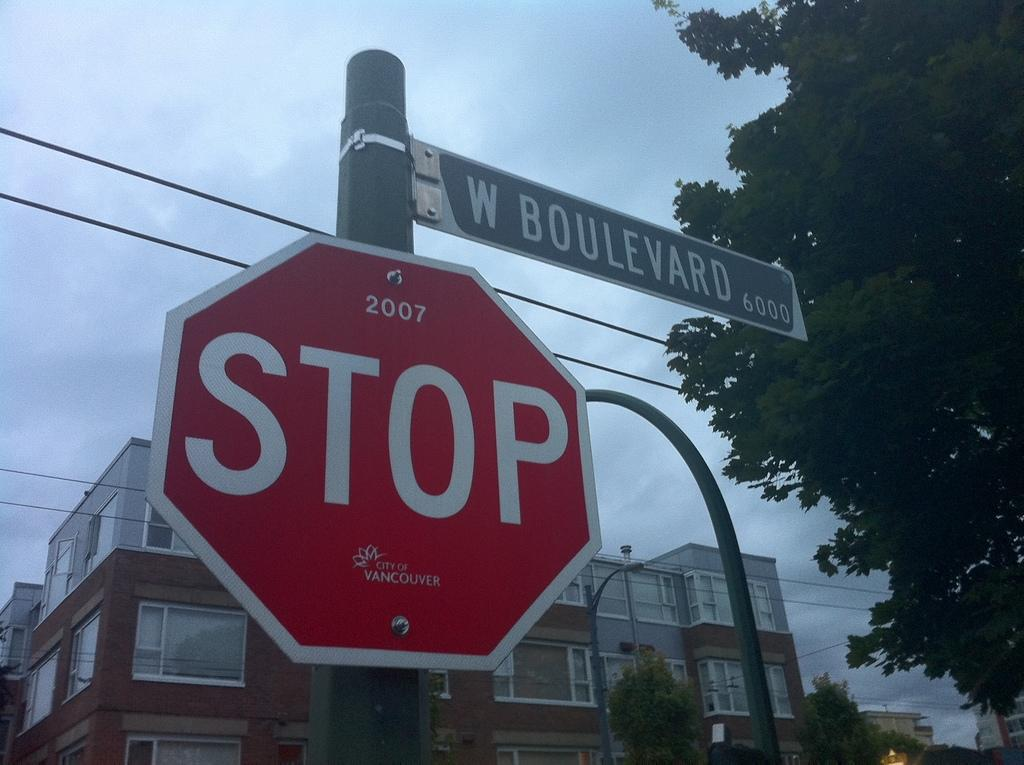<image>
Relay a brief, clear account of the picture shown. A red stop sign on a post with a street sign of W, Boulevard also attached to the post. 